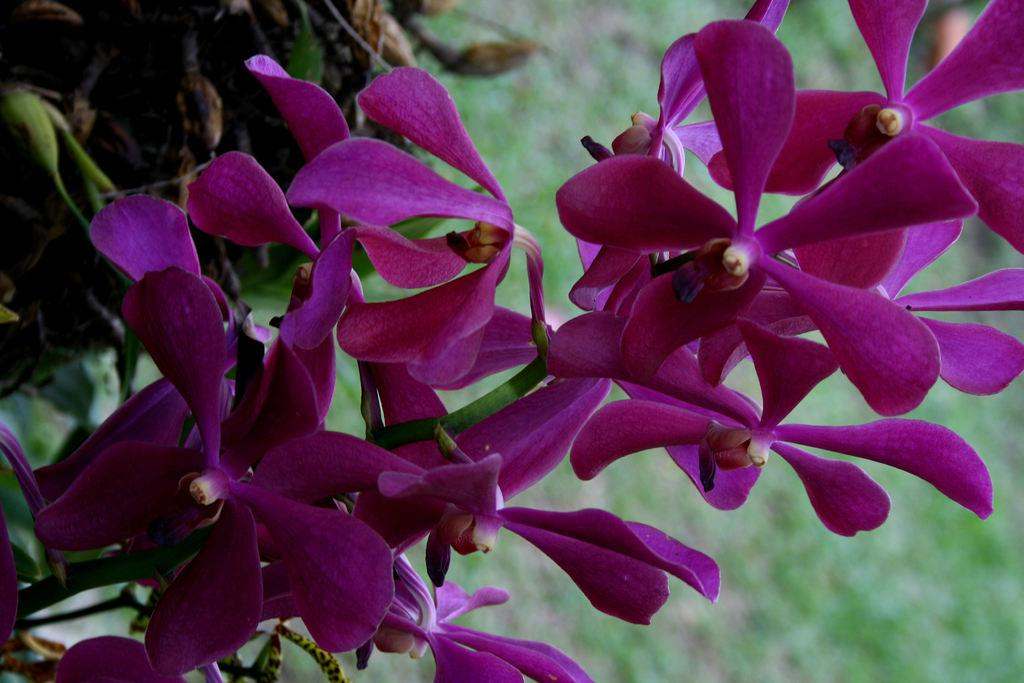What color are the flowers in the image? The flowers in the image are pink. Do the flowers have any visible parts besides the petals? Yes, the flowers have stems. What can be seen in the background of the image? There are plants visible in the background of the image, but they are not clearly visible. How does the queen use the mass in the image? There is no queen or mass present in the image; it features pink flowers with stems and plants in the background. 